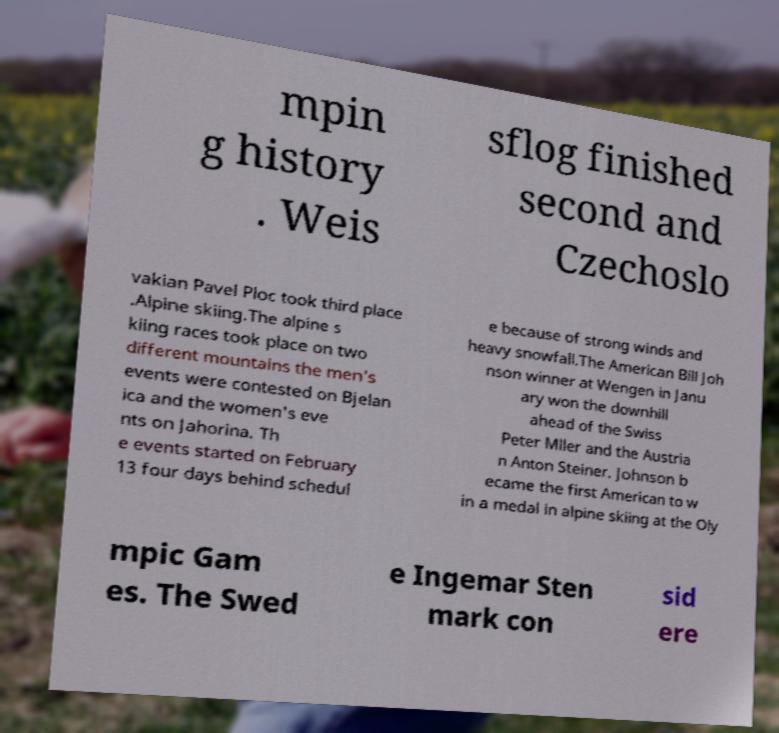I need the written content from this picture converted into text. Can you do that? mpin g history . Weis sflog finished second and Czechoslo vakian Pavel Ploc took third place .Alpine skiing.The alpine s kiing races took place on two different mountains the men's events were contested on Bjelan ica and the women's eve nts on Jahorina. Th e events started on February 13 four days behind schedul e because of strong winds and heavy snowfall.The American Bill Joh nson winner at Wengen in Janu ary won the downhill ahead of the Swiss Peter Mller and the Austria n Anton Steiner. Johnson b ecame the first American to w in a medal in alpine skiing at the Oly mpic Gam es. The Swed e Ingemar Sten mark con sid ere 